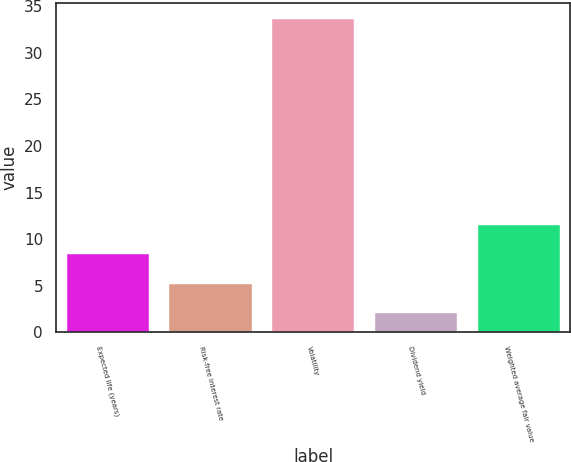Convert chart to OTSL. <chart><loc_0><loc_0><loc_500><loc_500><bar_chart><fcel>Expected life (years)<fcel>Risk-free interest rate<fcel>Volatility<fcel>Dividend yield<fcel>Weighted average fair value<nl><fcel>8.34<fcel>5.17<fcel>33.7<fcel>2<fcel>11.51<nl></chart> 